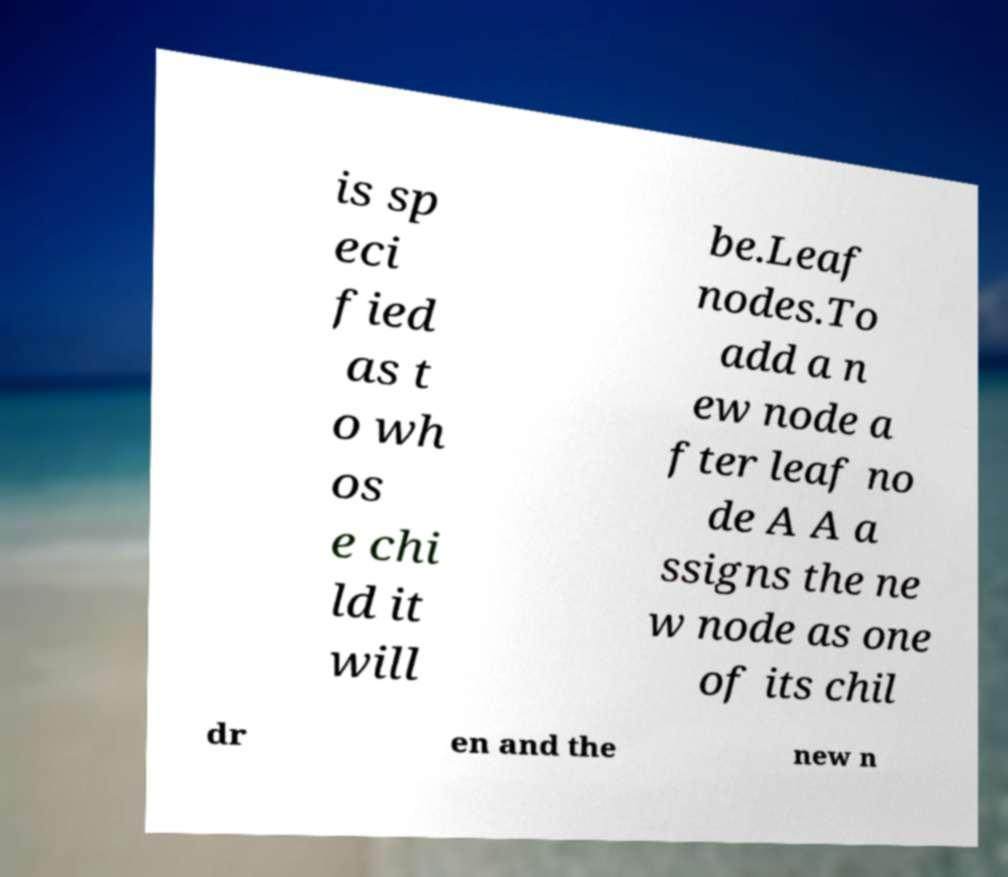Please read and relay the text visible in this image. What does it say? is sp eci fied as t o wh os e chi ld it will be.Leaf nodes.To add a n ew node a fter leaf no de A A a ssigns the ne w node as one of its chil dr en and the new n 